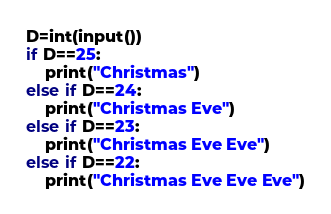<code> <loc_0><loc_0><loc_500><loc_500><_Python_>D=int(input())
if D==25:
    print("Christmas")
else if D==24:
    print("Christmas Eve")
else if D==23:
    print("Christmas Eve Eve")
else if D==22:
    print("Christmas Eve Eve Eve")</code> 